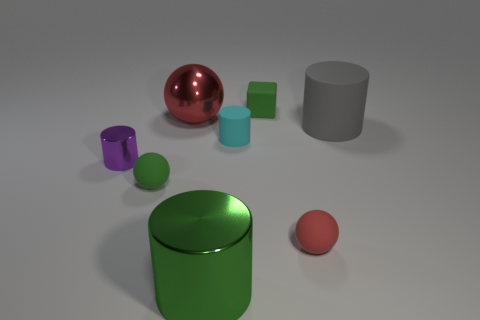Subtract 1 cylinders. How many cylinders are left? 3 Add 2 small cyan things. How many objects exist? 10 Subtract all cubes. How many objects are left? 7 Add 8 green rubber blocks. How many green rubber blocks are left? 9 Add 1 tiny purple metallic cubes. How many tiny purple metallic cubes exist? 1 Subtract 0 brown spheres. How many objects are left? 8 Subtract all blocks. Subtract all shiny cylinders. How many objects are left? 5 